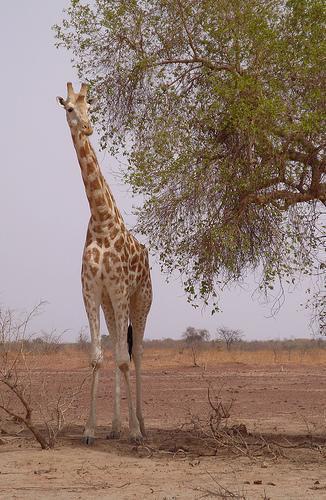How many legs are in this picture?
Give a very brief answer. 4. How many giraffe?
Give a very brief answer. 1. How many legs does the giraffe have?
Give a very brief answer. 4. 